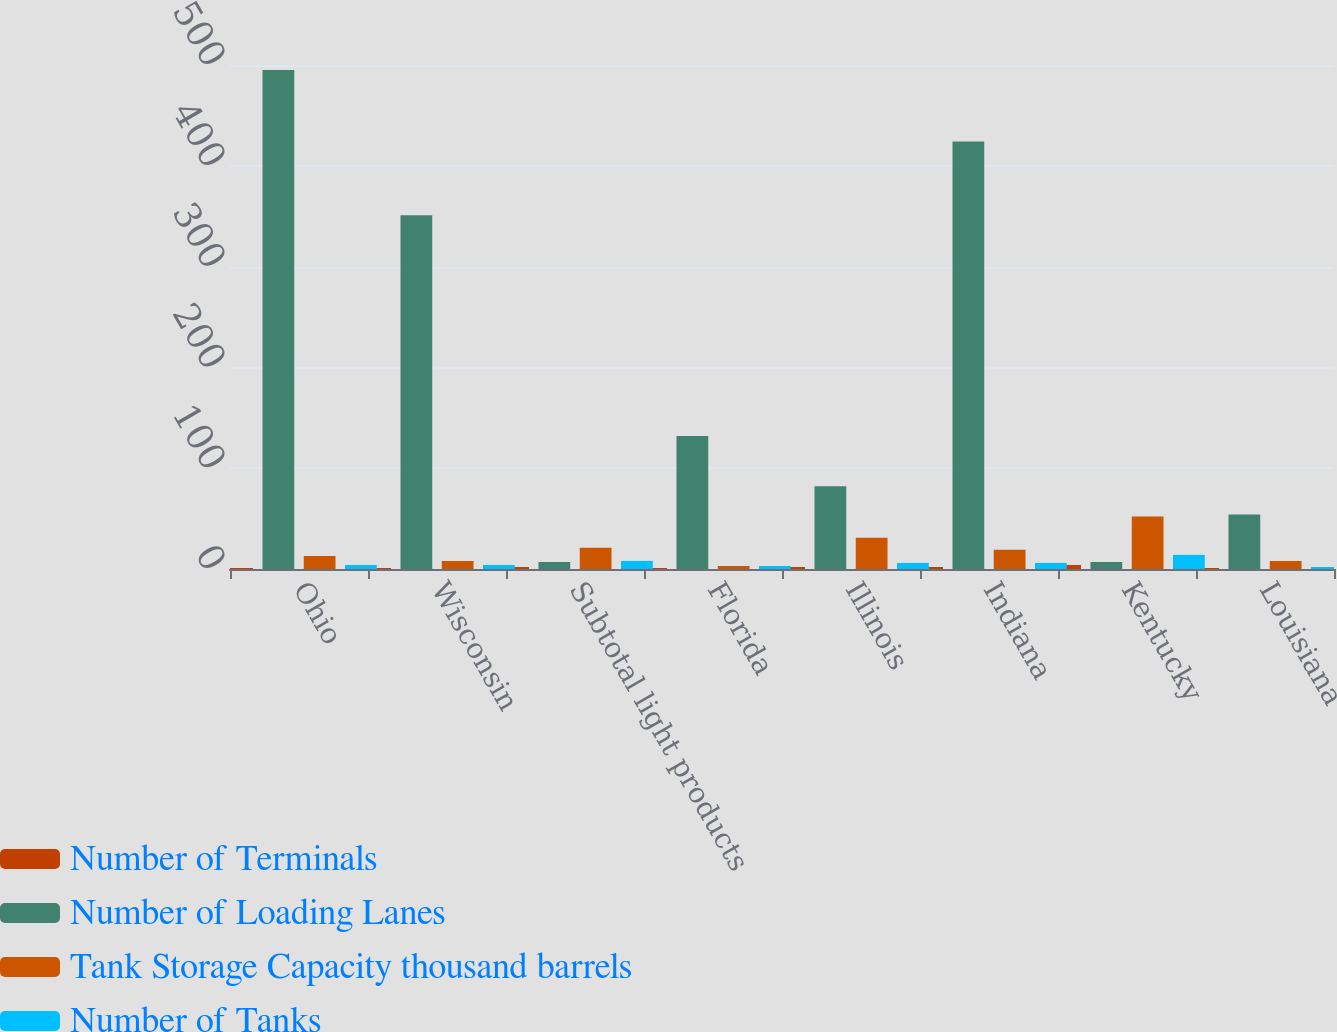<chart> <loc_0><loc_0><loc_500><loc_500><stacked_bar_chart><ecel><fcel>Ohio<fcel>Wisconsin<fcel>Subtotal light products<fcel>Florida<fcel>Illinois<fcel>Indiana<fcel>Kentucky<fcel>Louisiana<nl><fcel>Number of Terminals<fcel>1<fcel>1<fcel>2<fcel>1<fcel>2<fcel>2<fcel>4<fcel>1<nl><fcel>Number of Loading Lanes<fcel>495<fcel>351<fcel>7<fcel>132<fcel>82<fcel>424<fcel>7<fcel>54<nl><fcel>Tank Storage Capacity thousand barrels<fcel>13<fcel>8<fcel>21<fcel>3<fcel>31<fcel>19<fcel>52<fcel>8<nl><fcel>Number of Tanks<fcel>4<fcel>4<fcel>8<fcel>3<fcel>6<fcel>6<fcel>14<fcel>2<nl></chart> 